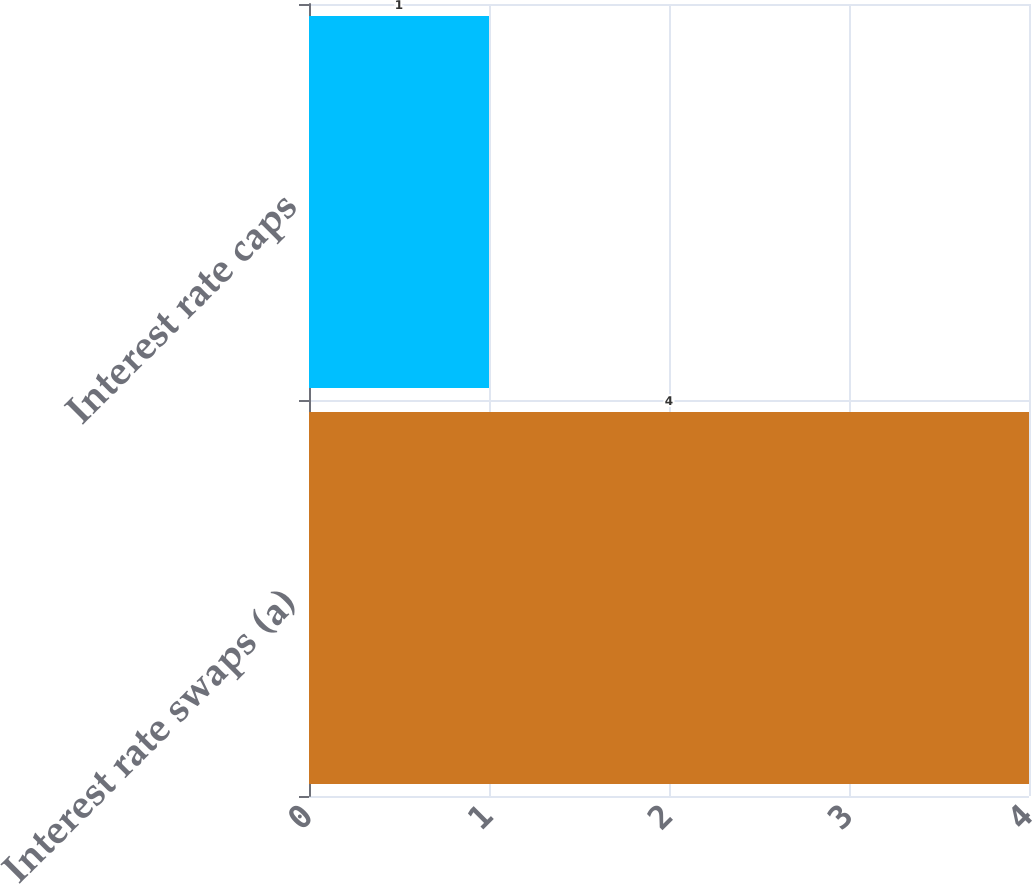<chart> <loc_0><loc_0><loc_500><loc_500><bar_chart><fcel>Interest rate swaps (a)<fcel>Interest rate caps<nl><fcel>4<fcel>1<nl></chart> 